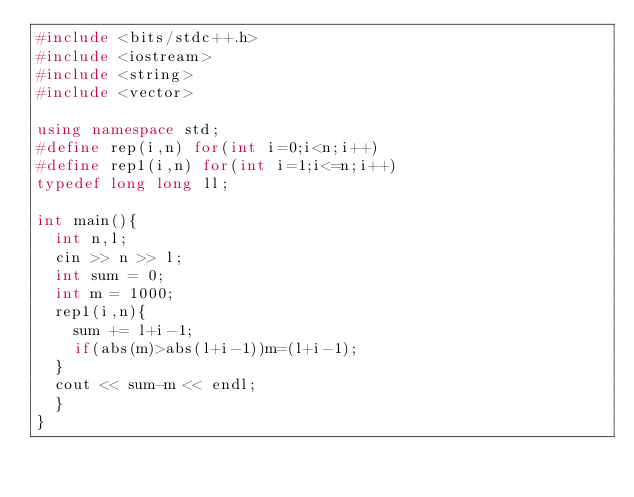Convert code to text. <code><loc_0><loc_0><loc_500><loc_500><_C++_>#include <bits/stdc++.h>
#include <iostream>
#include <string>
#include <vector>

using namespace std;
#define rep(i,n) for(int i=0;i<n;i++)
#define rep1(i,n) for(int i=1;i<=n;i++)
typedef long long ll;

int main(){
  int n,l;
  cin >> n >> l;
  int sum = 0;
  int m = 1000;
  rep1(i,n){
    sum += l+i-1;
    if(abs(m)>abs(l+i-1))m=(l+i-1);
  }
  cout << sum-m << endl;
  }
}
</code> 